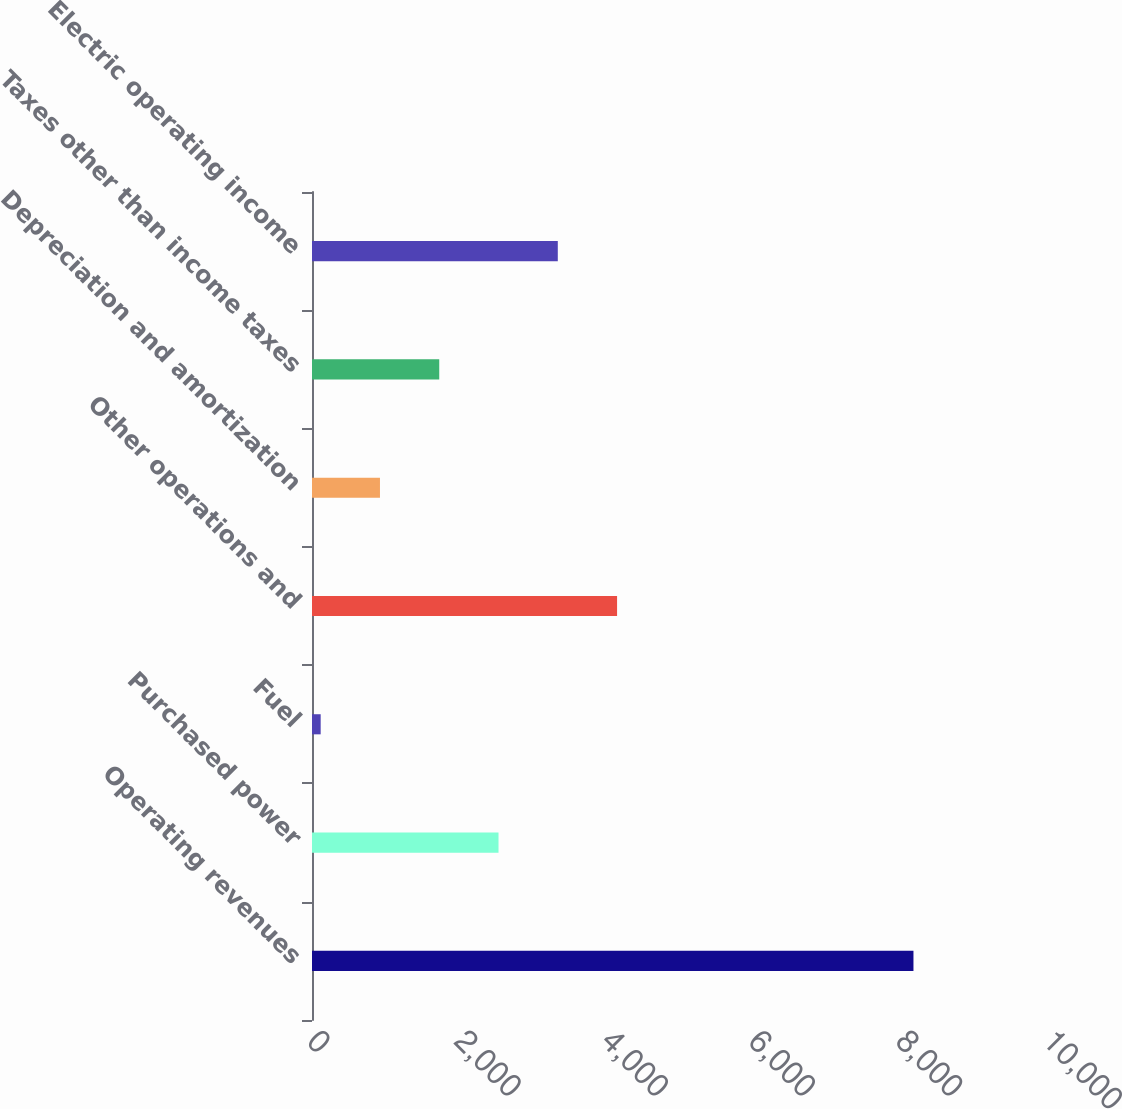<chart> <loc_0><loc_0><loc_500><loc_500><bar_chart><fcel>Operating revenues<fcel>Purchased power<fcel>Fuel<fcel>Other operations and<fcel>Depreciation and amortization<fcel>Taxes other than income taxes<fcel>Electric operating income<nl><fcel>8172<fcel>2534.2<fcel>118<fcel>4145<fcel>923.4<fcel>1728.8<fcel>3339.6<nl></chart> 